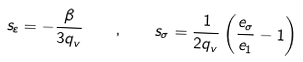<formula> <loc_0><loc_0><loc_500><loc_500>s _ { \varepsilon } = - \frac { \beta } { 3 q _ { v } } \quad , \quad s _ { \sigma } = \frac { 1 } { 2 q _ { v } } \left ( \frac { e _ { \sigma } } { e _ { 1 } } - 1 \right )</formula> 